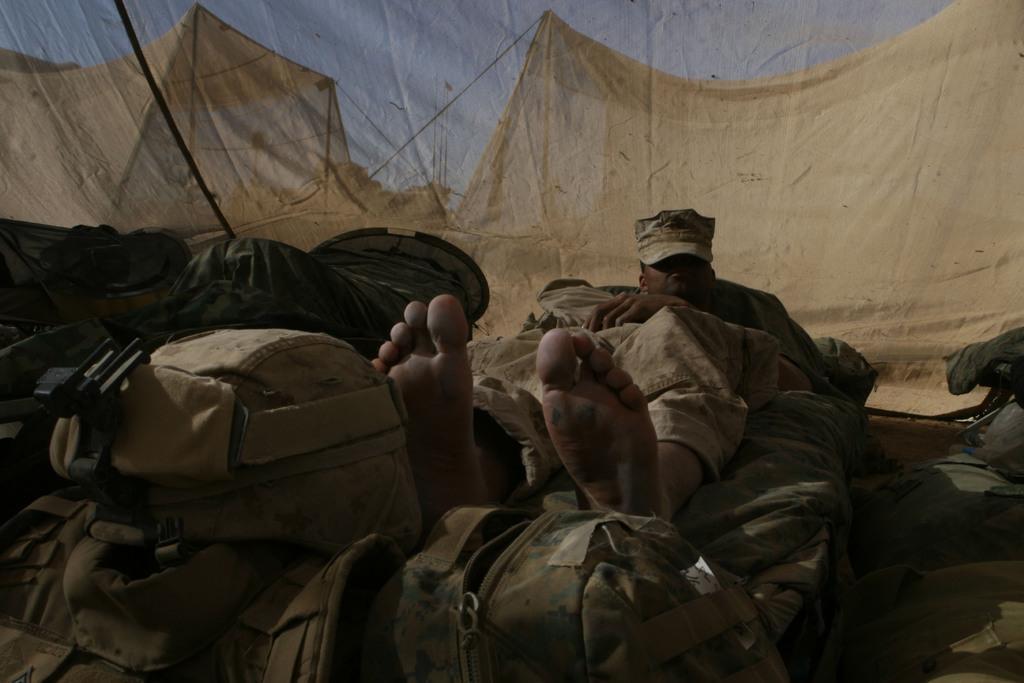Can you describe this image briefly? In this picture I can see a man, there are bags at the bottom. In the background there are tents, at the top there is the sky. 